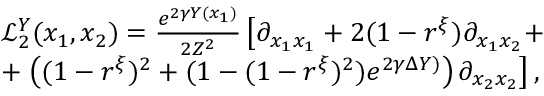Convert formula to latex. <formula><loc_0><loc_0><loc_500><loc_500>\begin{array} { r l } & { \mathcal { L } _ { 2 } ^ { Y } ( x _ { 1 } , x _ { 2 } ) = \frac { e ^ { 2 \gamma Y ( x _ { 1 } ) } } { 2 Z ^ { 2 } } \left [ \partial _ { x _ { 1 } x _ { 1 } } + 2 ( 1 - r ^ { \xi } ) \partial _ { x _ { 1 } x _ { 2 } } + } \\ & { + \left ( ( 1 - r ^ { \xi } ) ^ { 2 } + ( 1 - ( 1 - r ^ { \xi } ) ^ { 2 } ) e ^ { 2 \gamma \Delta Y ) } \right ) \partial _ { x _ { 2 } x _ { 2 } } \right ] , } \end{array}</formula> 